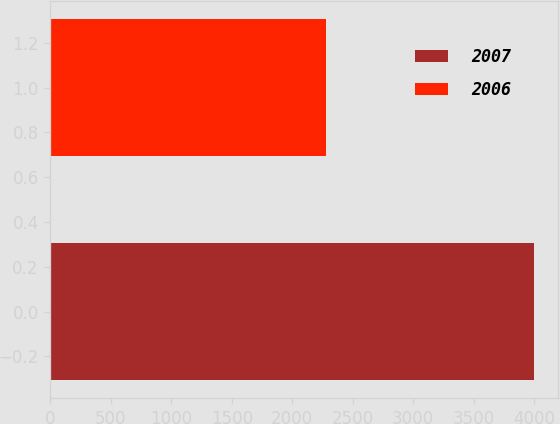Convert chart. <chart><loc_0><loc_0><loc_500><loc_500><bar_chart><fcel>2007<fcel>2006<nl><fcel>3999<fcel>2277<nl></chart> 